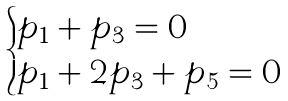<formula> <loc_0><loc_0><loc_500><loc_500>\begin{cases} p _ { 1 } + p _ { 3 } = 0 \\ p _ { 1 } + 2 p _ { 3 } + p _ { 5 } = 0 \end{cases}</formula> 